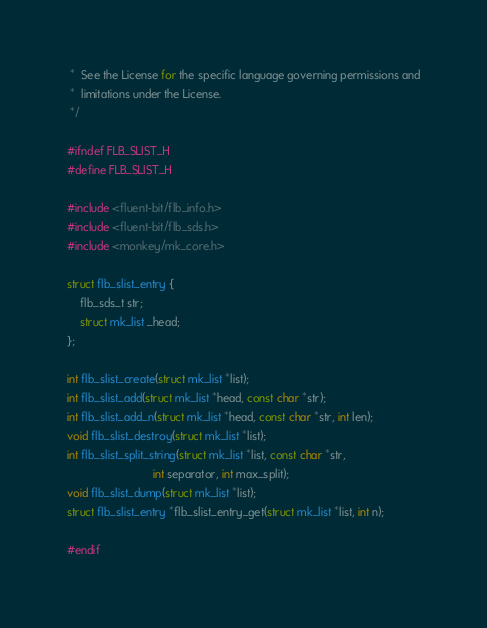<code> <loc_0><loc_0><loc_500><loc_500><_C_> *  See the License for the specific language governing permissions and
 *  limitations under the License.
 */

#ifndef FLB_SLIST_H
#define FLB_SLIST_H

#include <fluent-bit/flb_info.h>
#include <fluent-bit/flb_sds.h>
#include <monkey/mk_core.h>

struct flb_slist_entry {
    flb_sds_t str;
    struct mk_list _head;
};

int flb_slist_create(struct mk_list *list);
int flb_slist_add(struct mk_list *head, const char *str);
int flb_slist_add_n(struct mk_list *head, const char *str, int len);
void flb_slist_destroy(struct mk_list *list);
int flb_slist_split_string(struct mk_list *list, const char *str,
                           int separator, int max_split);
void flb_slist_dump(struct mk_list *list);
struct flb_slist_entry *flb_slist_entry_get(struct mk_list *list, int n);

#endif
</code> 